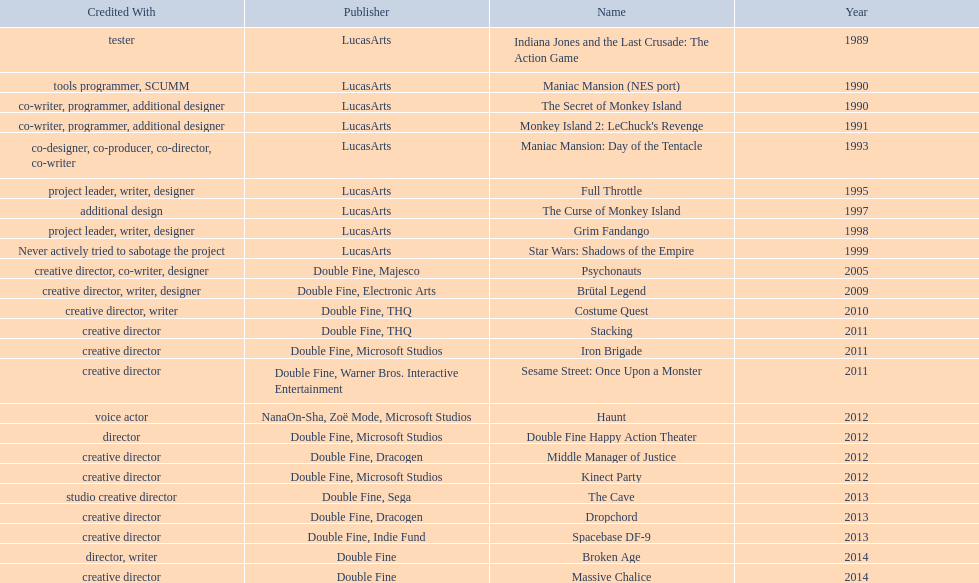What game name has tim schafer been involved with? Indiana Jones and the Last Crusade: The Action Game, Maniac Mansion (NES port), The Secret of Monkey Island, Monkey Island 2: LeChuck's Revenge, Maniac Mansion: Day of the Tentacle, Full Throttle, The Curse of Monkey Island, Grim Fandango, Star Wars: Shadows of the Empire, Psychonauts, Brütal Legend, Costume Quest, Stacking, Iron Brigade, Sesame Street: Once Upon a Monster, Haunt, Double Fine Happy Action Theater, Middle Manager of Justice, Kinect Party, The Cave, Dropchord, Spacebase DF-9, Broken Age, Massive Chalice. Which game has credit with just creative director? Creative director, creative director, creative director, creative director, creative director, creative director, creative director, creative director. Which games have the above and warner bros. interactive entertainment as publisher? Sesame Street: Once Upon a Monster. 